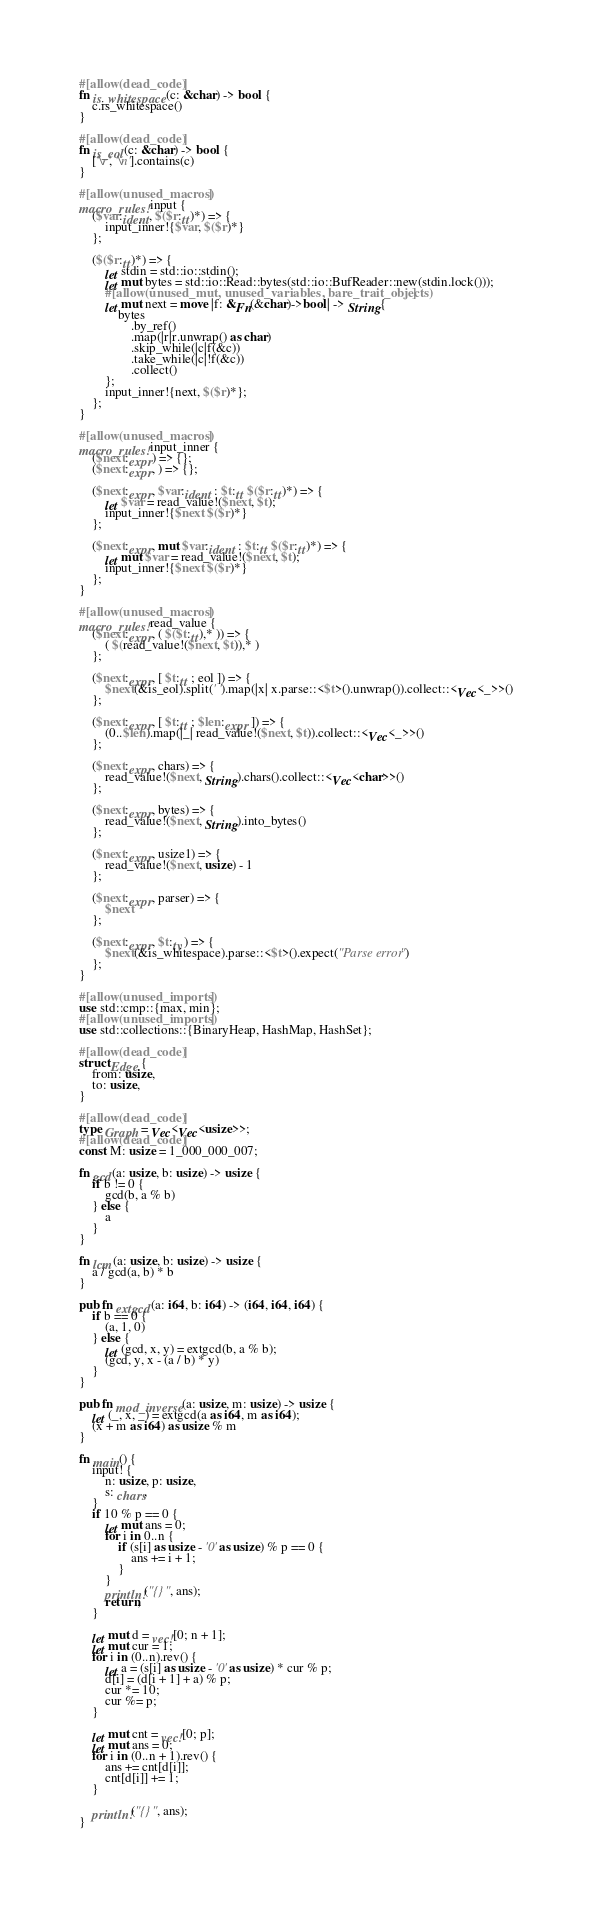<code> <loc_0><loc_0><loc_500><loc_500><_Rust_>#[allow(dead_code)]
fn is_whitespace(c: &char) -> bool {
    c.is_whitespace()
}

#[allow(dead_code)]
fn is_eol(c: &char) -> bool {
    ['\r', '\n'].contains(c)
}

#[allow(unused_macros)]
macro_rules! input {
    ($var:ident, $($r:tt)*) => {
        input_inner!{$var, $($r)*}
    };

    ($($r:tt)*) => {
        let stdin = std::io::stdin();
        let mut bytes = std::io::Read::bytes(std::io::BufReader::new(stdin.lock()));
        #[allow(unused_mut, unused_variables, bare_trait_objects)]
        let mut next = move |f: &Fn(&char)->bool| -> String{
            bytes
                .by_ref()
                .map(|r|r.unwrap() as char)
                .skip_while(|c|f(&c))
                .take_while(|c|!f(&c))
                .collect()
        };
        input_inner!{next, $($r)*};
    };
}

#[allow(unused_macros)]
macro_rules! input_inner {
    ($next:expr) => {};
    ($next:expr, ) => {};

    ($next:expr, $var:ident : $t:tt $($r:tt)*) => {
        let $var = read_value!($next, $t);
        input_inner!{$next $($r)*}
    };

    ($next:expr, mut $var:ident : $t:tt $($r:tt)*) => {
        let mut $var = read_value!($next, $t);
        input_inner!{$next $($r)*}
    };
}

#[allow(unused_macros)]
macro_rules! read_value {
    ($next:expr, ( $($t:tt),* )) => {
        ( $(read_value!($next, $t)),* )
    };

    ($next:expr, [ $t:tt ; eol ]) => {
        $next(&is_eol).split(' ').map(|x| x.parse::<$t>().unwrap()).collect::<Vec<_>>()
    };

    ($next:expr, [ $t:tt ; $len:expr ]) => {
        (0..$len).map(|_| read_value!($next, $t)).collect::<Vec<_>>()
    };

    ($next:expr, chars) => {
        read_value!($next, String).chars().collect::<Vec<char>>()
    };

    ($next:expr, bytes) => {
        read_value!($next, String).into_bytes()
    };

    ($next:expr, usize1) => {
        read_value!($next, usize) - 1
    };

    ($next:expr, parser) => {
        $next
    };

    ($next:expr, $t:ty) => {
        $next(&is_whitespace).parse::<$t>().expect("Parse error")
    };
}

#[allow(unused_imports)]
use std::cmp::{max, min};
#[allow(unused_imports)]
use std::collections::{BinaryHeap, HashMap, HashSet};

#[allow(dead_code)]
struct Edge {
    from: usize,
    to: usize,
}

#[allow(dead_code)]
type Graph = Vec<Vec<usize>>;
#[allow(dead_code)]
const M: usize = 1_000_000_007;

fn gcd(a: usize, b: usize) -> usize {
    if b != 0 {
        gcd(b, a % b)
    } else {
        a
    }
}

fn lcm(a: usize, b: usize) -> usize {
    a / gcd(a, b) * b
}

pub fn extgcd(a: i64, b: i64) -> (i64, i64, i64) {
    if b == 0 {
        (a, 1, 0)
    } else {
        let (gcd, x, y) = extgcd(b, a % b);
        (gcd, y, x - (a / b) * y)
    }
}

pub fn mod_inverse(a: usize, m: usize) -> usize {
    let (_, x, _) = extgcd(a as i64, m as i64);
    (x + m as i64) as usize % m
}

fn main() {
    input! {
        n: usize, p: usize,
        s: chars,
    }
    if 10 % p == 0 {
        let mut ans = 0;
        for i in 0..n {
            if (s[i] as usize - '0' as usize) % p == 0 {
                ans += i + 1;
            }
        }
        println!("{}", ans);
        return;
    }

    let mut d = vec![0; n + 1];
    let mut cur = 1;
    for i in (0..n).rev() {
        let a = (s[i] as usize - '0' as usize) * cur % p;
        d[i] = (d[i + 1] + a) % p;
        cur *= 10;
        cur %= p;
    }

    let mut cnt = vec![0; p];
    let mut ans = 0;
    for i in (0..n + 1).rev() {
        ans += cnt[d[i]];
        cnt[d[i]] += 1;
    }

    println!("{}", ans);
}
</code> 